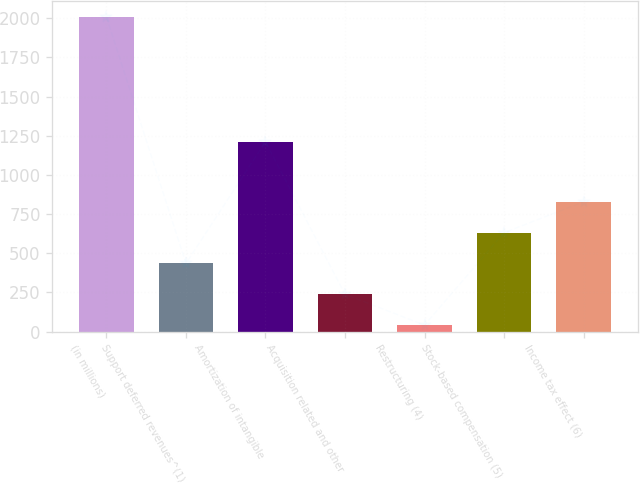Convert chart. <chart><loc_0><loc_0><loc_500><loc_500><bar_chart><fcel>(in millions)<fcel>Support deferred revenues^(1)<fcel>Amortization of intangible<fcel>Acquisition related and other<fcel>Restructuring (4)<fcel>Stock-based compensation (5)<fcel>Income tax effect (6)<nl><fcel>2008<fcel>434.4<fcel>1212<fcel>237.7<fcel>41<fcel>631.1<fcel>827.8<nl></chart> 